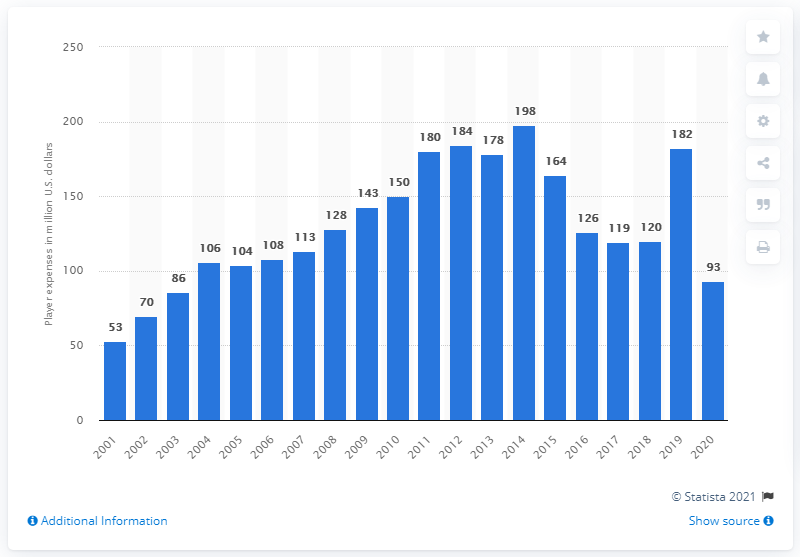Outline some significant characteristics in this image. The payroll of the Philadelphia Phillies in 2020 was approximately 93 million dollars. 